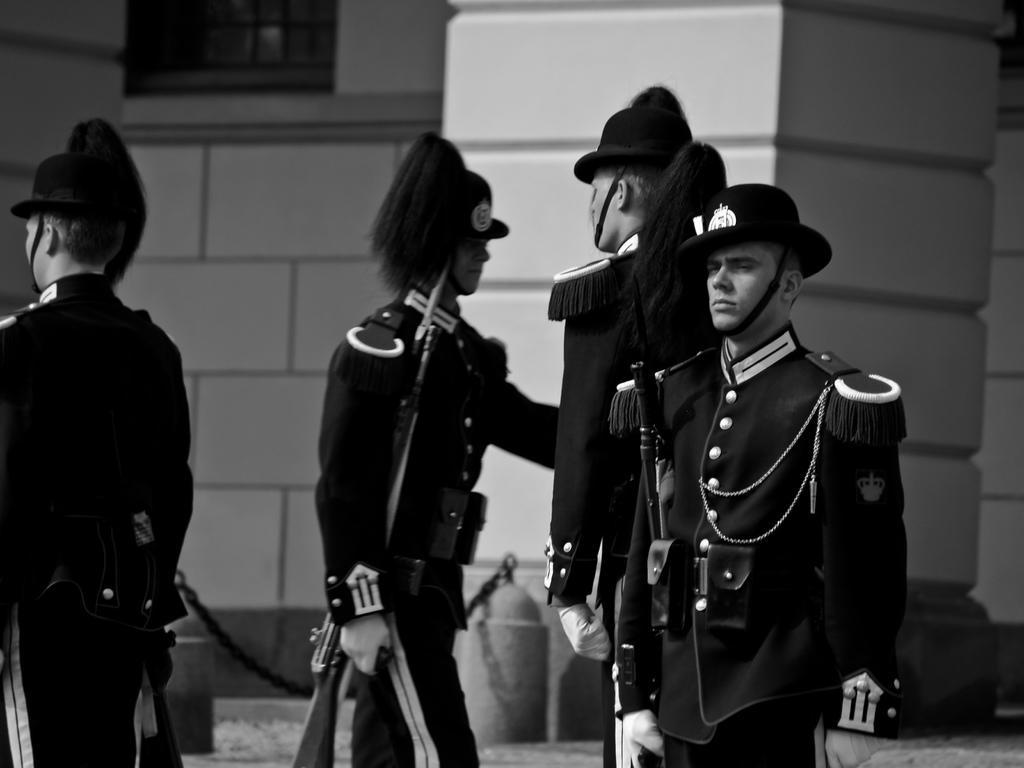Could you give a brief overview of what you see in this image? In this picture there are four persons who are wearing same dress and holding the gun. In the back I can see the building. At the top left there is a window. 